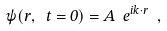Convert formula to latex. <formula><loc_0><loc_0><loc_500><loc_500>\psi ( r , \ t = 0 ) = A \ e ^ { i k \cdot r } \ ,</formula> 